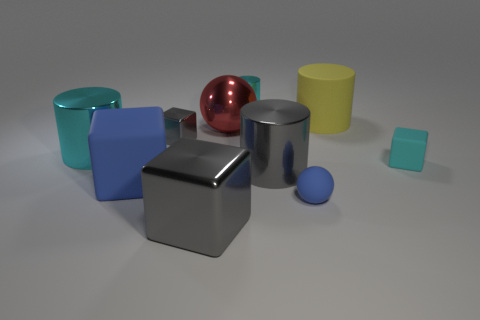Subtract 1 cubes. How many cubes are left? 3 Subtract all blocks. How many objects are left? 6 Subtract all large blue cubes. Subtract all big cyan things. How many objects are left? 8 Add 1 metallic spheres. How many metallic spheres are left? 2 Add 5 big red cylinders. How many big red cylinders exist? 5 Subtract 0 purple balls. How many objects are left? 10 